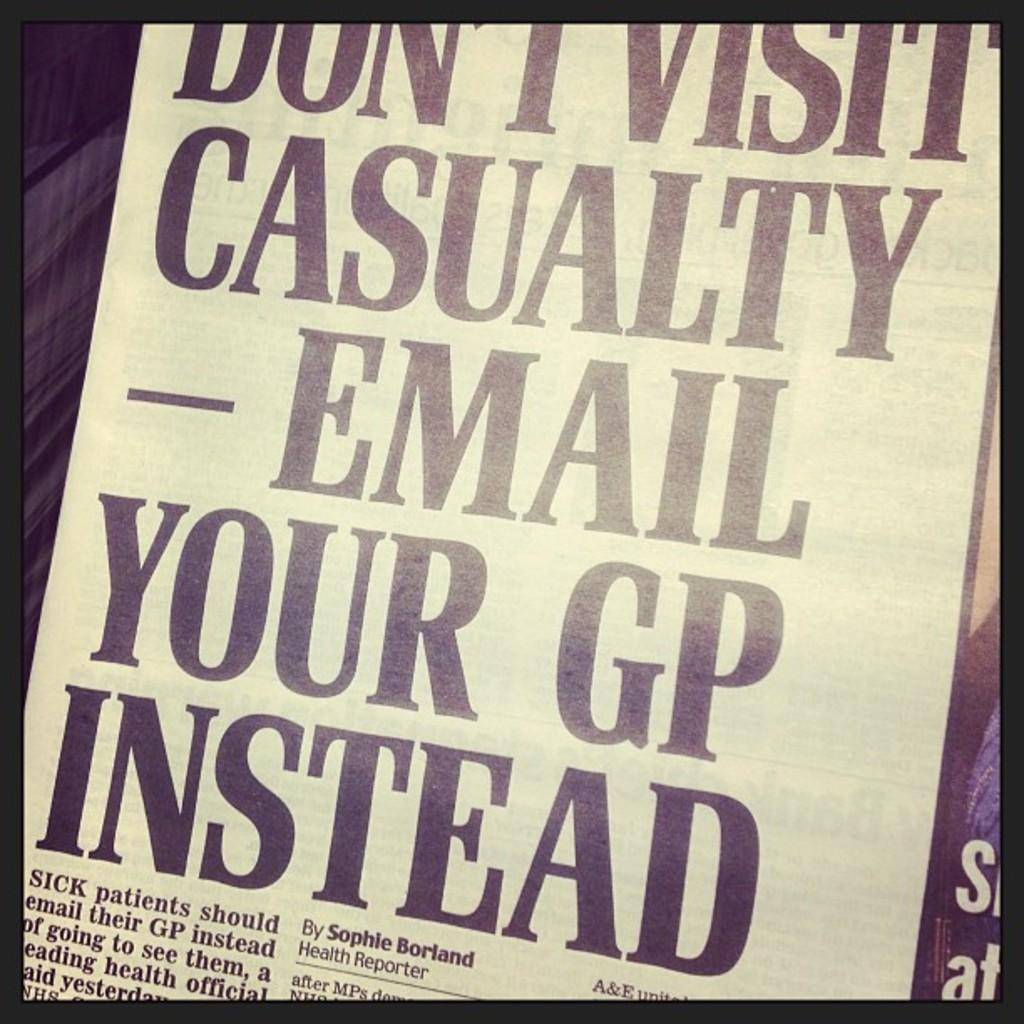<image>
Offer a succinct explanation of the picture presented. A sign telling people they should email their GP 